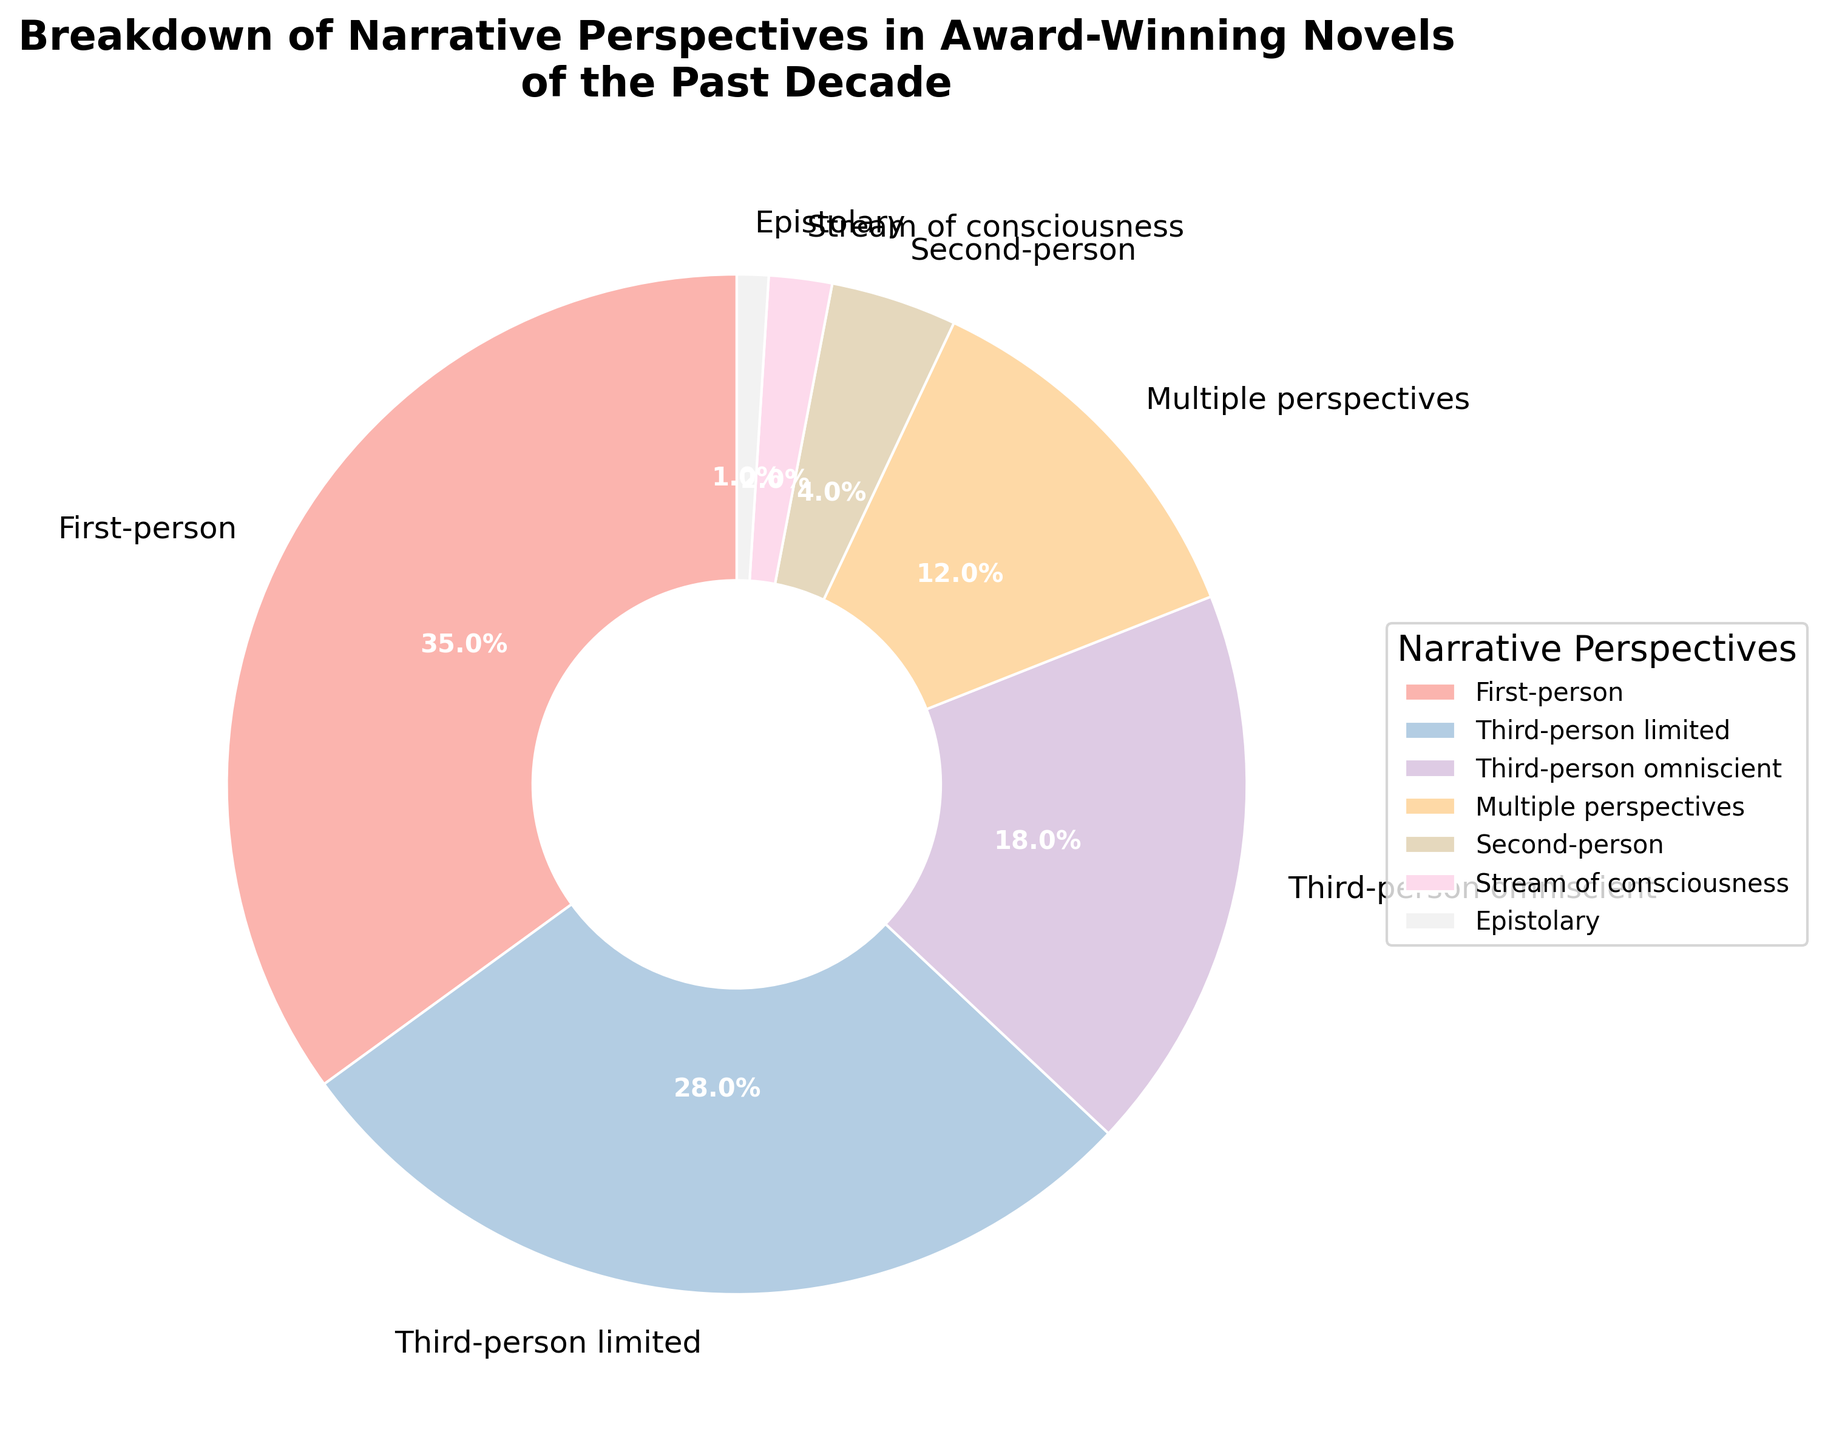Which narrative perspective is the most commonly used in award-winning novels of the past decade? To find the most commonly used narrative perspective, look at the slice with the largest percentage. From the figure, the largest slice is labeled "First-person" with 35%.
Answer: First-person Which narrative perspectives combined make up less than 10% of the total? Add the percentages of the smallest sections until the total is less than 10%. The smallest sections are "Epistolary" (1%), "Stream of consciousness" (2%), and "Second-person" (4%), which total 7%.
Answer: Epistolary, Stream of consciousness, Second-person What is the difference in the percentage between the most common and the least common narrative perspective? Identify the most common (First-person at 35%) and the least common (Epistolary at 1%) perspectives, then subtract the smaller from the larger: 35% - 1% = 34%.
Answer: 34% Are there more novels written in third-person (combining third-person limited and third-person omniscient) or in first-person? Calculate the sum of third-person limited (28%) and third-person omniscient (18%) to compare it with first-person. The total for third-person is 28% + 18% = 46%. First-person is 35%, so third-person has a higher percentage.
Answer: Third-person What is the percentage gap between third-person limited and multiple perspectives? Subtract the smaller percentage (Multiple perspectives at 12%) from the larger one (Third-person limited at 28%): 28% - 12% = 16%.
Answer: 16% Considering only the top three narrative perspectives, what percentage of novels do they account for? Add the percentages of the top three narrative perspectives: First-person (35%), Third-person limited (28%), and Third-person omniscient (18%). 35% + 28% + 18% = 81%.
Answer: 81% Which narrative perspective is represented by the smallest segment in the pie chart? Look for the smallest slice in the pie chart, which is labeled "Epistolary" with 1%.
Answer: Epistolary How does the usage of second-person narrative compare to third-person omniscient? Compare the percentages of second-person (4%) and third-person omniscient (18%). Third-person omniscient is greater by 18% - 4% = 14%.
Answer: Third-person omniscient is higher by 14% What percentage of novels use either stream of consciousness or multiple perspectives? Add the percentages of "Stream of Consciousness" (2%) and "Multiple Perspectives" (12%): 2% + 12% = 14%.
Answer: 14% 